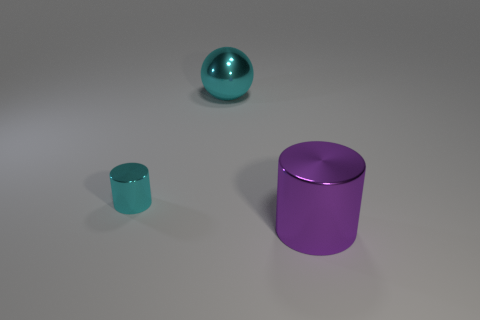Are there any other things that have the same size as the cyan metal cylinder?
Make the answer very short. No. Are there any big cyan shiny balls to the right of the small shiny cylinder?
Keep it short and to the point. Yes. Are there an equal number of small metallic cylinders that are right of the metallic sphere and small gray shiny things?
Offer a terse response. Yes. The thing that is the same size as the purple metallic cylinder is what shape?
Give a very brief answer. Sphere. What is the color of the thing that is in front of the cyan ball and to the right of the cyan metal cylinder?
Your answer should be very brief. Purple. Are there the same number of cyan metallic spheres in front of the tiny cyan cylinder and big cyan objects in front of the ball?
Your answer should be compact. Yes. There is another cylinder that is made of the same material as the tiny cylinder; what is its color?
Provide a succinct answer. Purple. Is the color of the ball the same as the cylinder that is behind the large purple shiny cylinder?
Offer a terse response. Yes. There is a cyan thing in front of the cyan thing behind the cyan shiny cylinder; are there any large metal objects that are behind it?
Your answer should be compact. Yes. The cyan object that is the same material as the cyan ball is what shape?
Your response must be concise. Cylinder. 